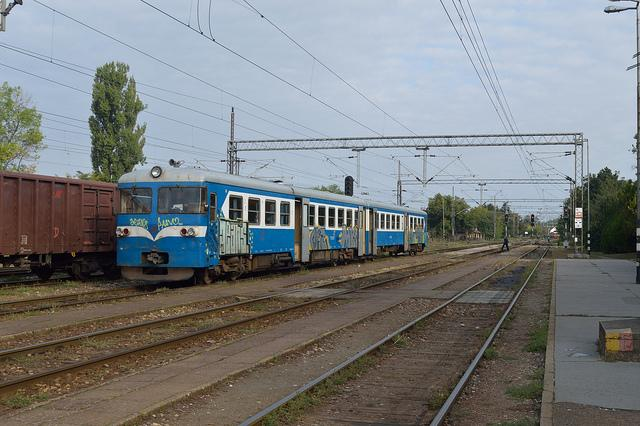What is the name of the painting on the outside of the blue train? Please explain your reasoning. graffiti. The name is graffiti. 